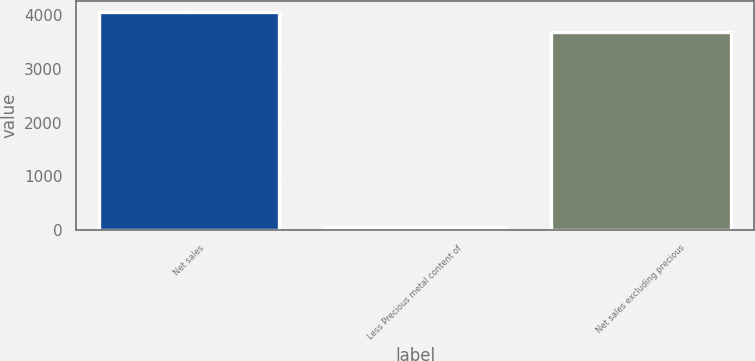Convert chart. <chart><loc_0><loc_0><loc_500><loc_500><bar_chart><fcel>Net sales<fcel>Less Precious metal content of<fcel>Net sales excluding precious<nl><fcel>4049.1<fcel>64.3<fcel>3681<nl></chart> 